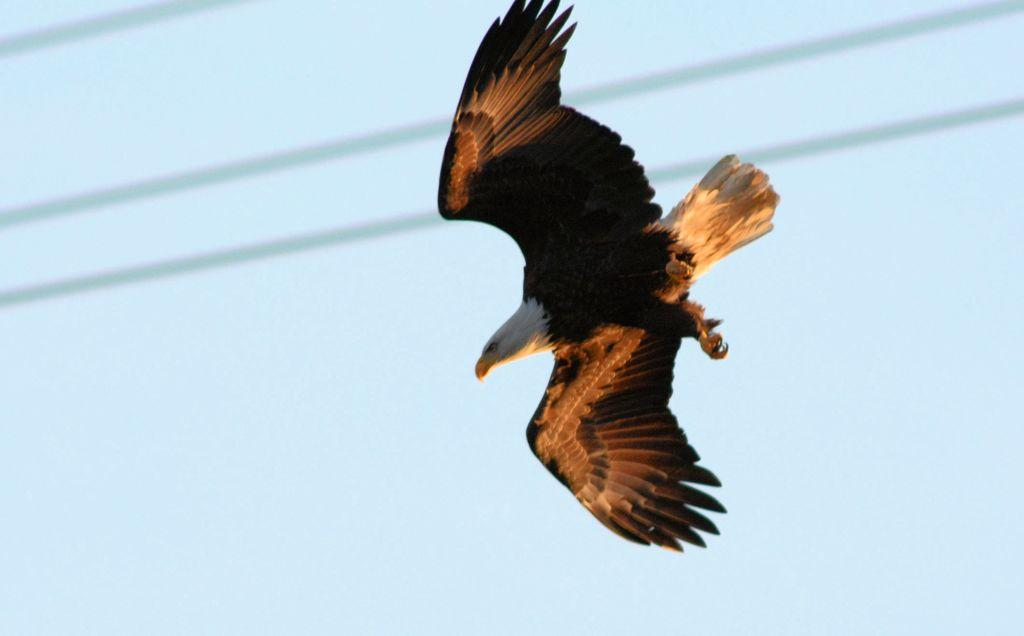What type of animal can be seen in the image? There is a bird in the image. What is the bird doing in the image? The bird is flying in the sky. What type of jam is the bird spreading on the road in the image? There is no jam or road present in the image; it only features a bird flying in the sky. 